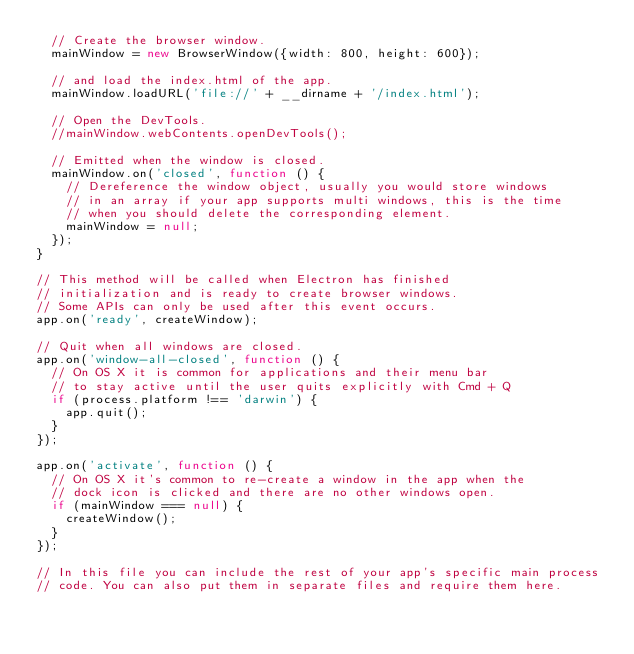<code> <loc_0><loc_0><loc_500><loc_500><_JavaScript_>  // Create the browser window.
  mainWindow = new BrowserWindow({width: 800, height: 600});

  // and load the index.html of the app.
  mainWindow.loadURL('file://' + __dirname + '/index.html');

  // Open the DevTools.
  //mainWindow.webContents.openDevTools();

  // Emitted when the window is closed.
  mainWindow.on('closed', function () {
    // Dereference the window object, usually you would store windows
    // in an array if your app supports multi windows, this is the time
    // when you should delete the corresponding element.
    mainWindow = null;
  });
}

// This method will be called when Electron has finished
// initialization and is ready to create browser windows.
// Some APIs can only be used after this event occurs.
app.on('ready', createWindow);

// Quit when all windows are closed.
app.on('window-all-closed', function () {
  // On OS X it is common for applications and their menu bar
  // to stay active until the user quits explicitly with Cmd + Q
  if (process.platform !== 'darwin') {
    app.quit();
  }
});

app.on('activate', function () {
  // On OS X it's common to re-create a window in the app when the
  // dock icon is clicked and there are no other windows open.
  if (mainWindow === null) {
    createWindow();
  }
});

// In this file you can include the rest of your app's specific main process
// code. You can also put them in separate files and require them here.

</code> 